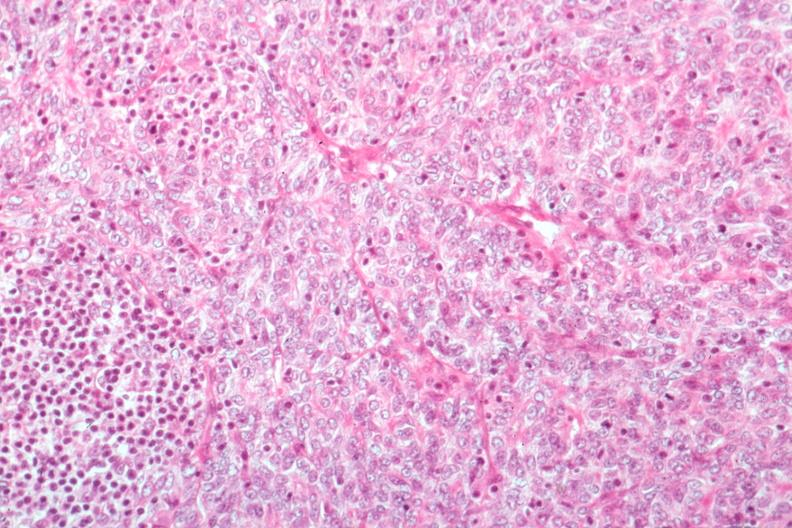what is present?
Answer the question using a single word or phrase. Thymus 